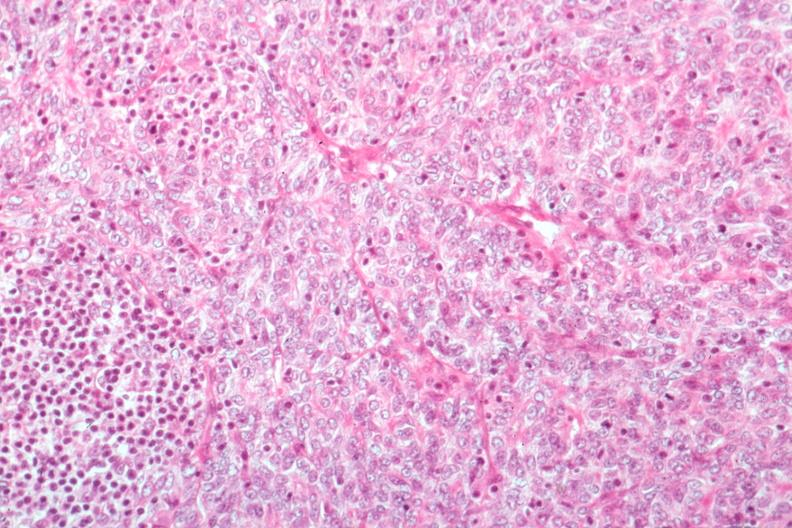what is present?
Answer the question using a single word or phrase. Thymus 